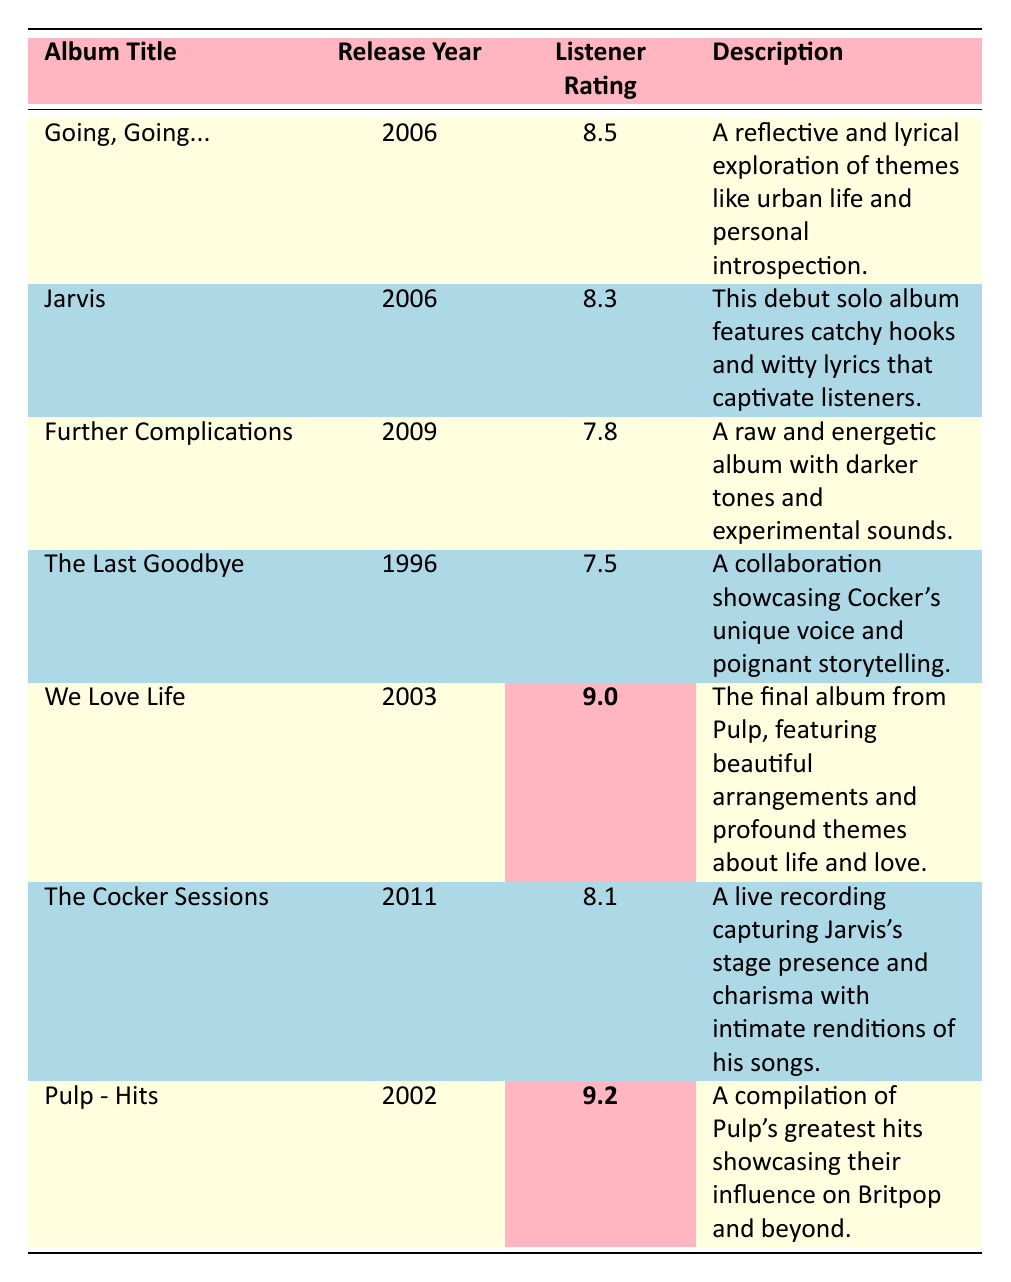What is the highest listener rating among the albums? We check the Listener Rating column, and the highest value listed is 9.2 associated with the album "Pulp - Hits."
Answer: 9.2 Which album was released in 2006 and has a rating above 8.0? The table shows two albums from 2006: "Going, Going..." with a rating of 8.5 and "Jarvis" with a rating of 8.3. Both have ratings above 8.0.
Answer: Going, Going... and Jarvis How many albums have a listener rating below 8.0? By looking at the Listener Rating column, "Further Complications" has a rating of 7.8 and "The Last Goodbye" has a rating of 7.5. That makes a total of 2 albums with ratings below 8.0.
Answer: 2 What is the difference in listener ratings between "We Love Life" and "Going, Going..."? "We Love Life" has a rating of 9.0 and "Going, Going..." has a rating of 8.5. The difference is 9.0 - 8.5 = 0.5.
Answer: 0.5 Is "The Last Goodbye" rated higher than 7.0? The table shows that "The Last Goodbye" has a rating of 7.5, which is indeed higher than 7.0.
Answer: Yes Which album has the lowest listener rating? We look through the Listener Rating column, and we find that "The Last Goodbye" has the lowest rating at 7.5.
Answer: The Last Goodbye What is the average listener rating of all the albums listed? To find the average, we add the ratings: 8.5 + 8.3 + 7.8 + 7.5 + 9.0 + 8.1 + 9.2 = 58.4, and then divide by 7 (the number of albums): 58.4 / 7 ≈ 8.34.
Answer: 8.34 What percentage of the albums have a rating of 8.0 or higher? There are 4 albums with ratings of 8.0 or higher: "Going, Going..." (8.5), "Jarvis" (8.3), "We Love Life" (9.0), and "Pulp - Hits" (9.2) out of 7 total albums. The percentage is (4/7) * 100 ≈ 57.14%.
Answer: Approximately 57.14% How many albums are from the 2000s? The table contains 5 albums from the 2000s: "Going, Going..." (2006), "Jarvis" (2006), "Further Complications" (2009), "We Love Life" (2003), and "Pulp - Hits" (2002).
Answer: 5 Is there an album released in 1996 with a rating lower than 8.0? "The Last Goodbye," released in 1996, has a rating of 7.5, which is lower than 8.0.
Answer: Yes 